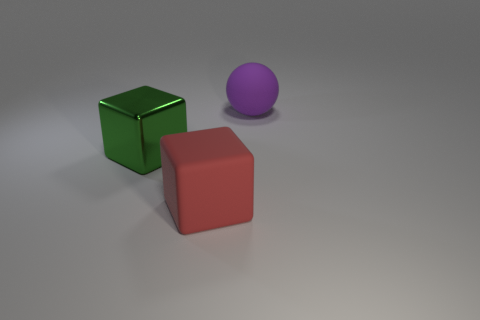Add 2 large matte blocks. How many objects exist? 5 Subtract all blocks. How many objects are left? 1 Add 3 green metallic objects. How many green metallic objects exist? 4 Subtract 0 yellow balls. How many objects are left? 3 Subtract all large red objects. Subtract all big purple matte spheres. How many objects are left? 1 Add 3 matte spheres. How many matte spheres are left? 4 